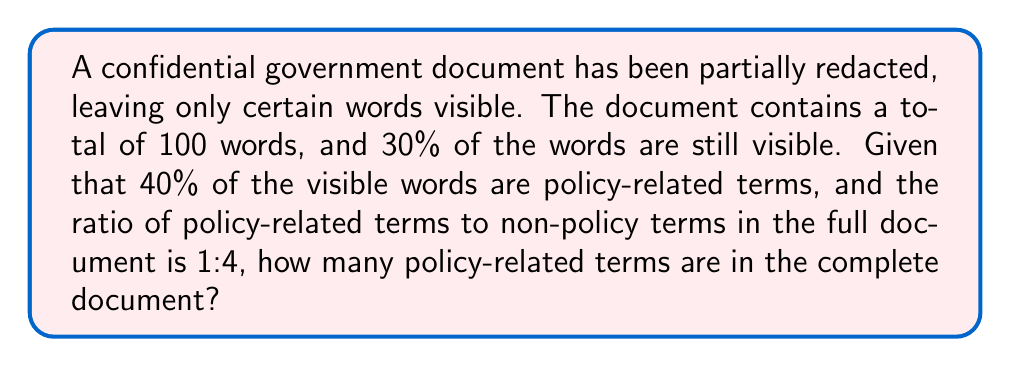Help me with this question. Let's approach this step-by-step:

1) First, let's identify the known information:
   - Total words in the document: 100
   - Percentage of visible words: 30%
   - Percentage of visible words that are policy-related: 40%
   - Ratio of policy-related to non-policy terms in full document: 1:4

2) Calculate the number of visible words:
   $$ \text{Visible words} = 100 \times 30\% = 30 \text{ words} $$

3) Calculate the number of visible policy-related terms:
   $$ \text{Visible policy terms} = 30 \times 40\% = 12 \text{ words} $$

4) Now, let's set up an equation. Let $x$ be the total number of policy-related terms in the full document:
   $$ \frac{x}{100-x} = \frac{1}{4} $$

5) Solve the equation:
   $$ 4x = 100 - x $$
   $$ 5x = 100 $$
   $$ x = 20 $$

6) Verify the result:
   - Policy-related terms: 20
   - Non-policy terms: 80
   - Ratio: 20:80 = 1:4 (which matches the given ratio)

7) Cross-check with visible words:
   - 12 out of 20 policy-related terms are visible (60%)
   - 18 out of 80 non-policy terms are visible (22.5%)
   - Total visible: 30 out of 100 (30%, which matches the given information)
Answer: 20 policy-related terms 